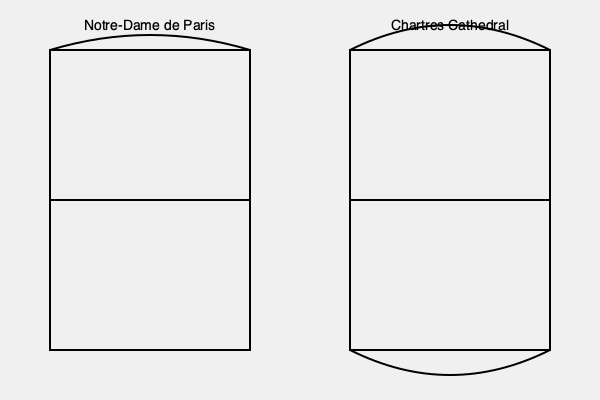Analyze the floor plans of Notre-Dame de Paris and Chartres Cathedral as depicted in the illustration. How do these plans reflect the evolution of Gothic architecture, and what specific elements in each plan demonstrate the cathedrals' respective periods within the Gothic style? To answer this question, we need to examine the floor plans closely and consider the historical context of Gothic architecture:

1. Notre-Dame de Paris (early Gothic, 12th-13th century):
   a. The plan shows a simpler, more rectangular nave.
   b. The apse (semicircular area at the top) is relatively shallow.
   c. The transept (horizontal arm) is less pronounced.
   d. These features indicate an earlier stage of Gothic architecture, transitioning from Romanesque.

2. Chartres Cathedral (High Gothic, 13th century):
   a. The plan reveals a more complex structure with a deeper apse.
   b. The transept is more prominent, creating a distinct cross shape.
   c. The ambulatory (path around the apse) appears more developed.
   d. These elements suggest a more mature Gothic style.

3. Evolution of Gothic architecture:
   a. Notre-Dame represents the early experimentation with Gothic forms.
   b. Chartres showcases the refinement and elaboration of these forms.
   c. The progression from a simpler to a more complex plan reflects the increasing architectural ambition and technical skill of Gothic builders.

4. Specific elements demonstrating periods:
   a. Notre-Dame's shallower apse and less pronounced transept indicate its earlier construction and closer ties to Romanesque traditions.
   b. Chartres' deeper apse, prominent transept, and more intricate overall plan exemplify the High Gothic period's emphasis on verticality and light.

5. Theological and aesthetic implications:
   a. The more complex plan of Chartres reflects the growing importance of pilgrimages and the need for circulation space around the altar.
   b. The emphasis on the cross shape in Chartres' plan underscores the increasing focus on symbolism in Gothic architecture.

These floor plans thus illustrate the transition from Early to High Gothic, showcasing the style's evolution towards greater complexity, symbolism, and architectural ambition.
Answer: Notre-Dame exemplifies Early Gothic with a simpler plan, while Chartres represents High Gothic with a more complex, cross-shaped plan, demonstrating the style's evolution towards greater intricacy and symbolism. 